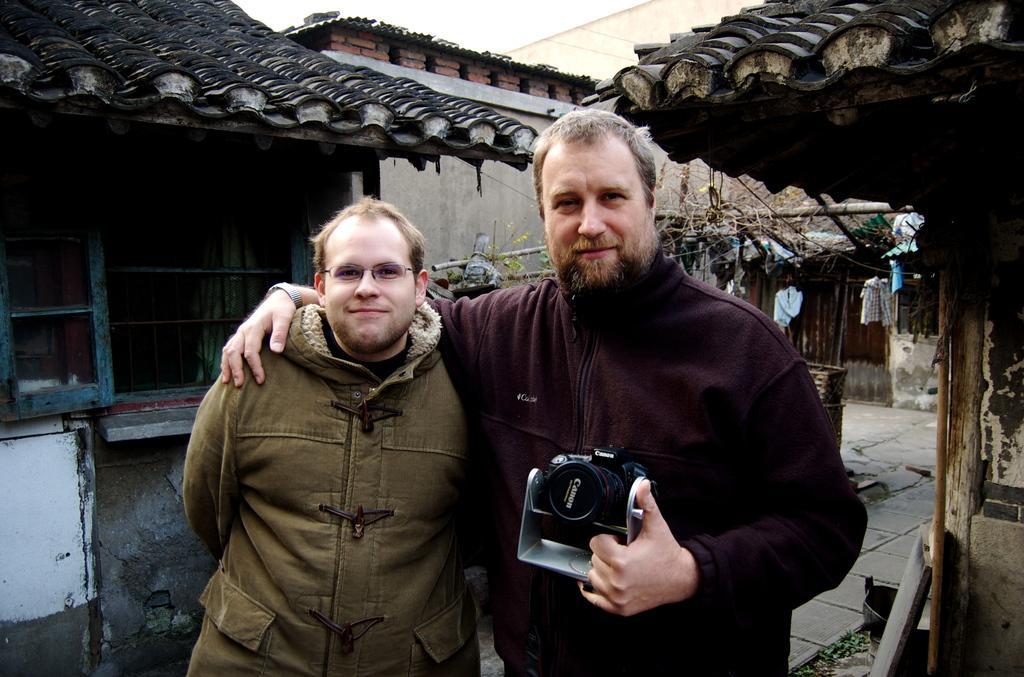In one or two sentences, can you explain what this image depicts? In this picture there is a person standing in right corner is holding a camera with one of his hand and placed his other hand on a person standing beside him and there are few houses behind them. 